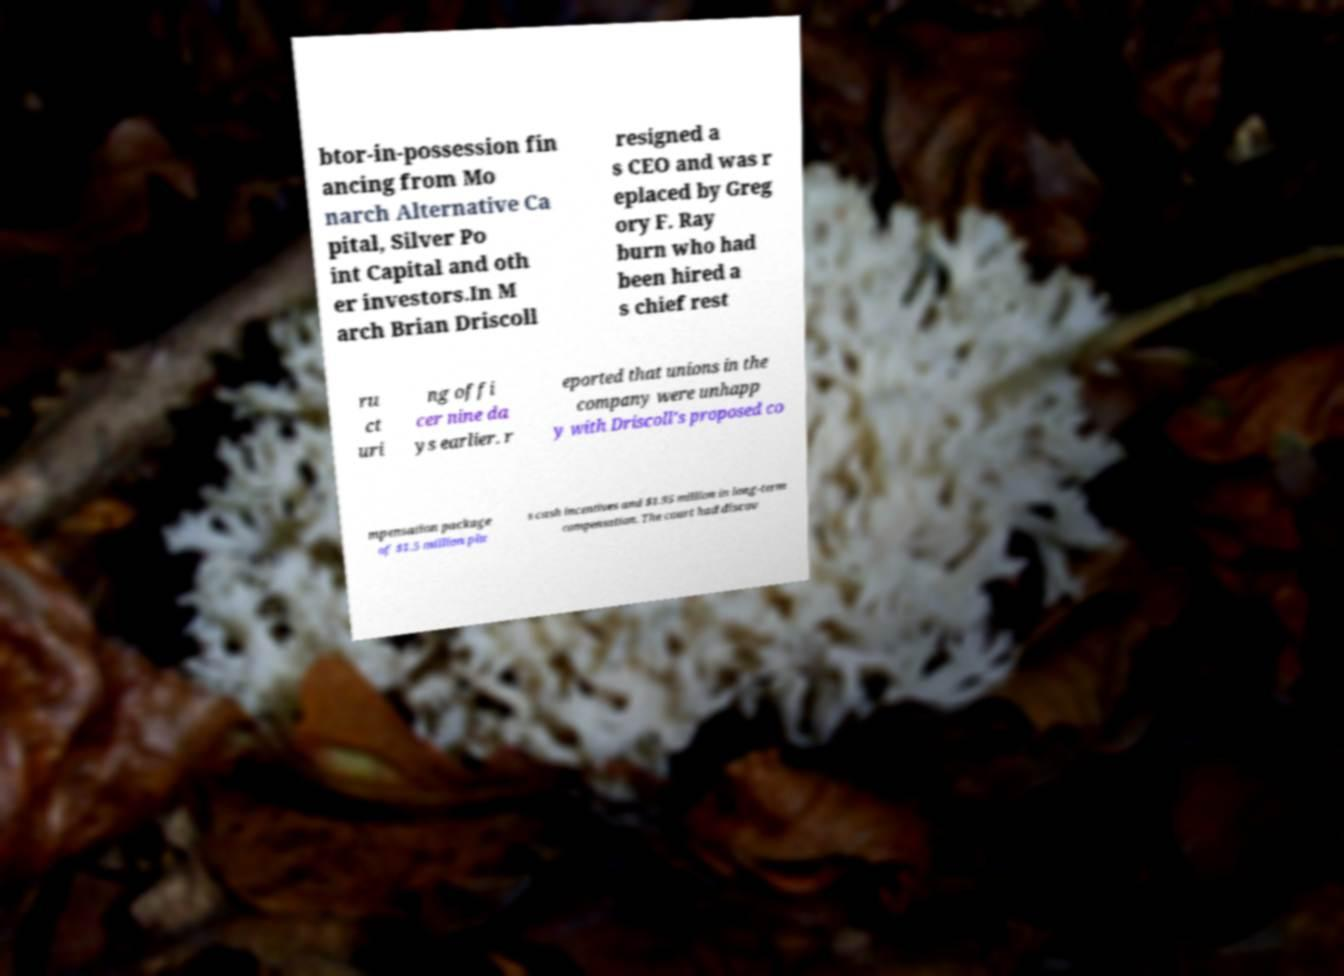I need the written content from this picture converted into text. Can you do that? btor-in-possession fin ancing from Mo narch Alternative Ca pital, Silver Po int Capital and oth er investors.In M arch Brian Driscoll resigned a s CEO and was r eplaced by Greg ory F. Ray burn who had been hired a s chief rest ru ct uri ng offi cer nine da ys earlier. r eported that unions in the company were unhapp y with Driscoll's proposed co mpensation package of $1.5 million plu s cash incentives and $1.95 million in long-term compensation. The court had discov 